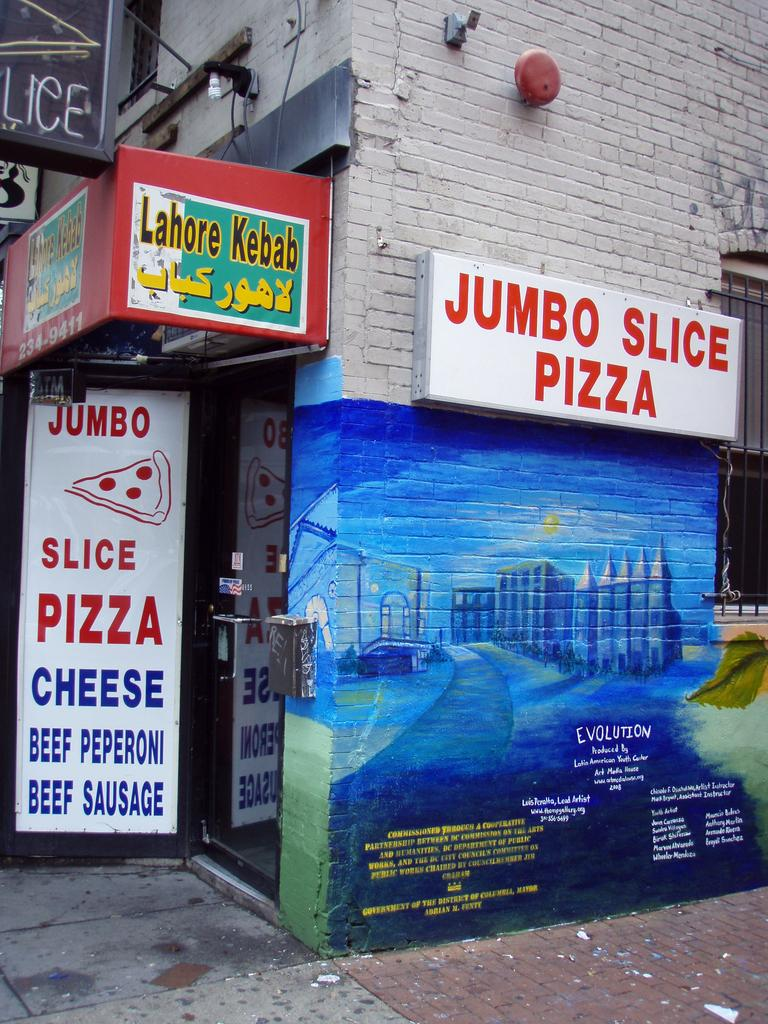What can be seen on the sign boards in the image? There are sign boards with text in the image. Where are the sign boards located? The sign boards are placed on a building. What type of illumination is present in the image? There is a light in the image. What other object can be seen in the image? There is a bell in the image. What can be seen in the background of the image? There is a window visible in the background of the image. How many hills can be seen in the image? There are no hills visible in the image. What type of grain is stored in the drawer in the image? There is no drawer or grain present in the image. 